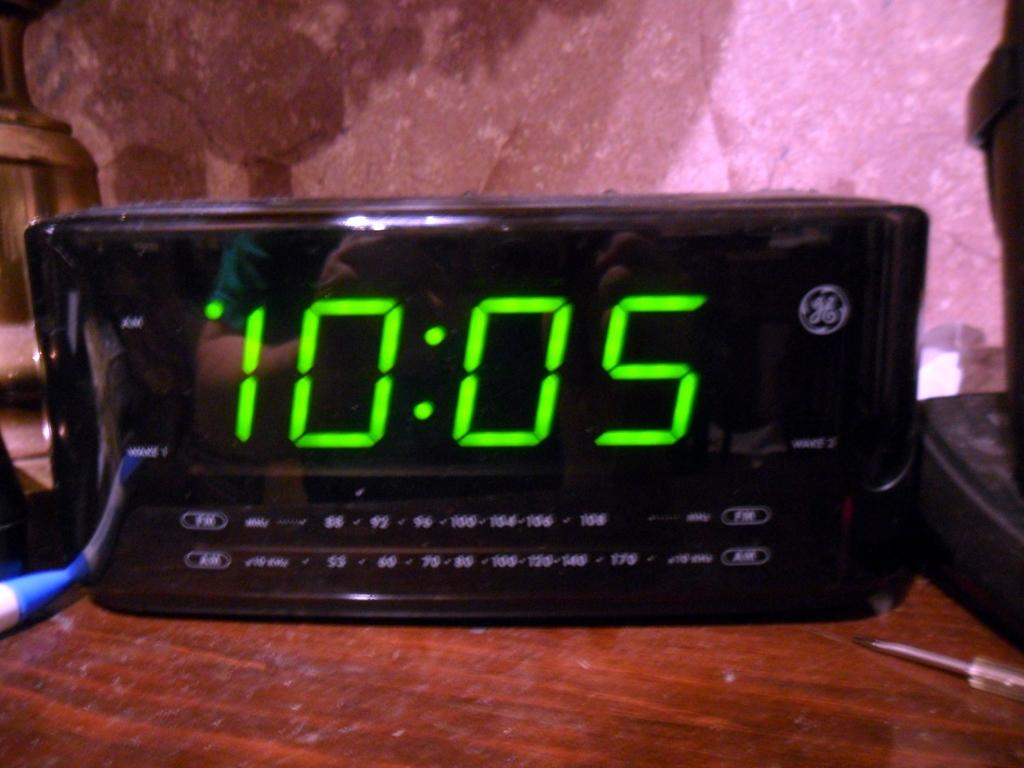Provide a one-sentence caption for the provided image. An alarm clock made by GE displays the time of 10:05. 